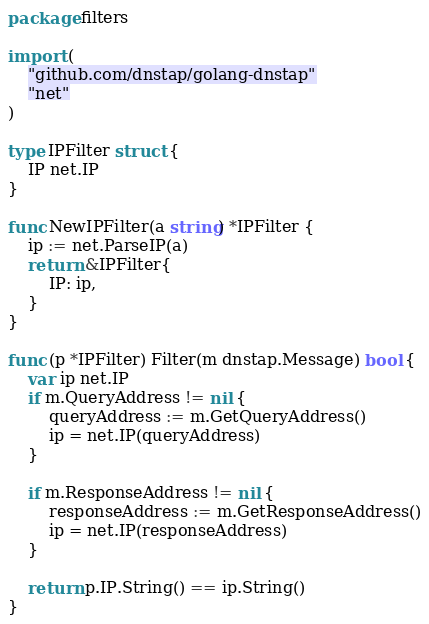Convert code to text. <code><loc_0><loc_0><loc_500><loc_500><_Go_>package filters

import (
	"github.com/dnstap/golang-dnstap"
	"net"
)

type IPFilter struct {
	IP net.IP
}

func NewIPFilter(a string) *IPFilter {
	ip := net.ParseIP(a)
	return &IPFilter{
		IP: ip,
	}
}

func (p *IPFilter) Filter(m dnstap.Message) bool {
	var ip net.IP
	if m.QueryAddress != nil {
		queryAddress := m.GetQueryAddress()
		ip = net.IP(queryAddress)
	}

	if m.ResponseAddress != nil {
		responseAddress := m.GetResponseAddress()
		ip = net.IP(responseAddress)
	}

	return p.IP.String() == ip.String()
}
</code> 